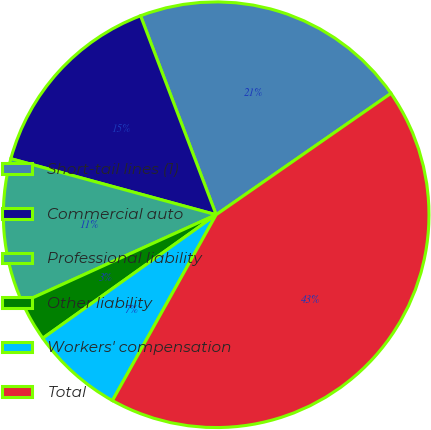Convert chart. <chart><loc_0><loc_0><loc_500><loc_500><pie_chart><fcel>Short-tail lines (1)<fcel>Commercial auto<fcel>Professional liability<fcel>Other liability<fcel>Workers' compensation<fcel>Total<nl><fcel>21.12%<fcel>14.98%<fcel>11.01%<fcel>3.08%<fcel>7.05%<fcel>42.76%<nl></chart> 